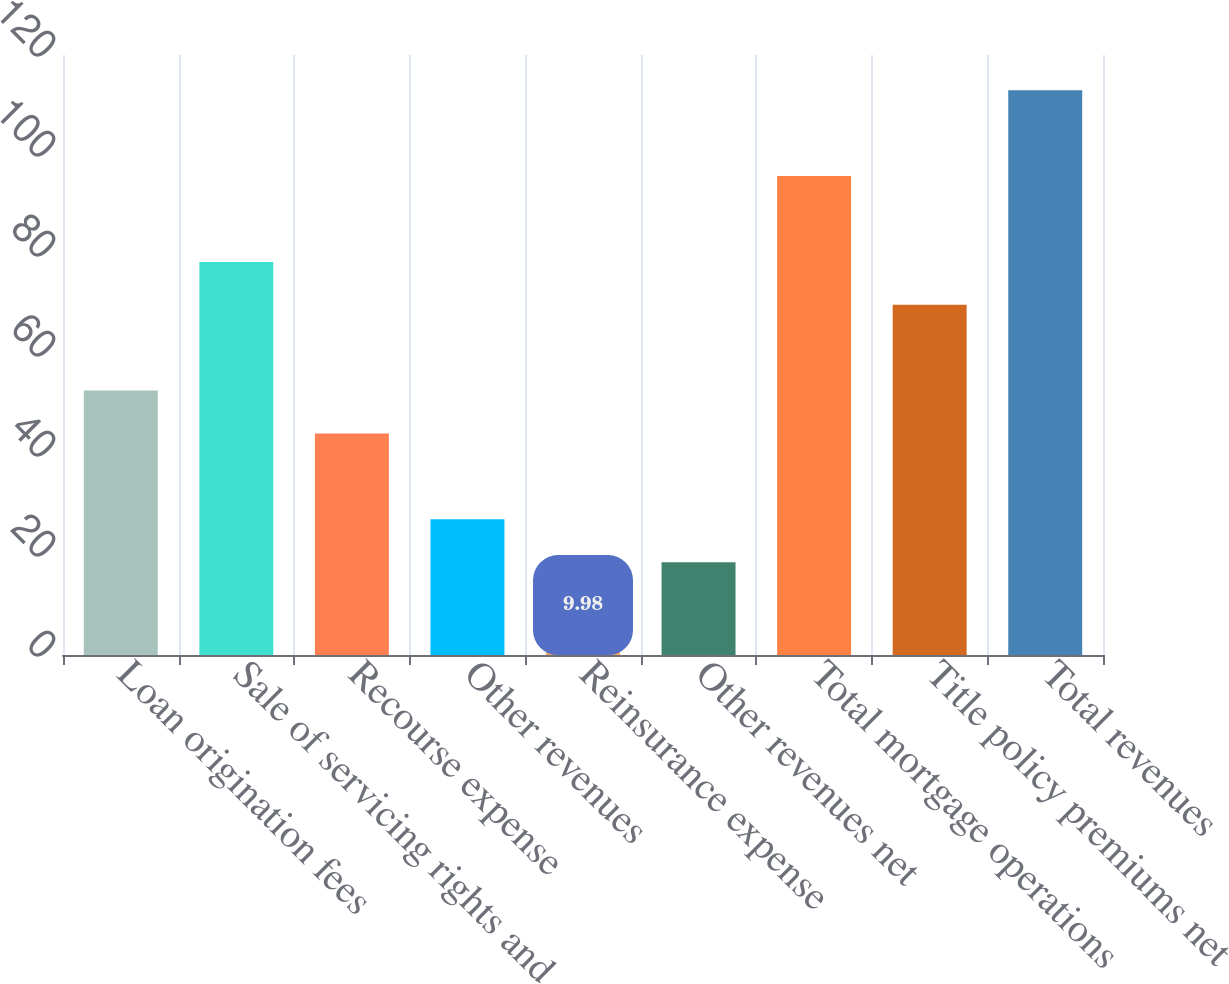Convert chart. <chart><loc_0><loc_0><loc_500><loc_500><bar_chart><fcel>Loan origination fees<fcel>Sale of servicing rights and<fcel>Recourse expense<fcel>Other revenues<fcel>Reinsurance expense<fcel>Other revenues net<fcel>Total mortgage operations<fcel>Title policy premiums net<fcel>Total revenues<nl><fcel>52.88<fcel>78.62<fcel>44.3<fcel>27.14<fcel>9.98<fcel>18.56<fcel>95.78<fcel>70.04<fcel>112.94<nl></chart> 